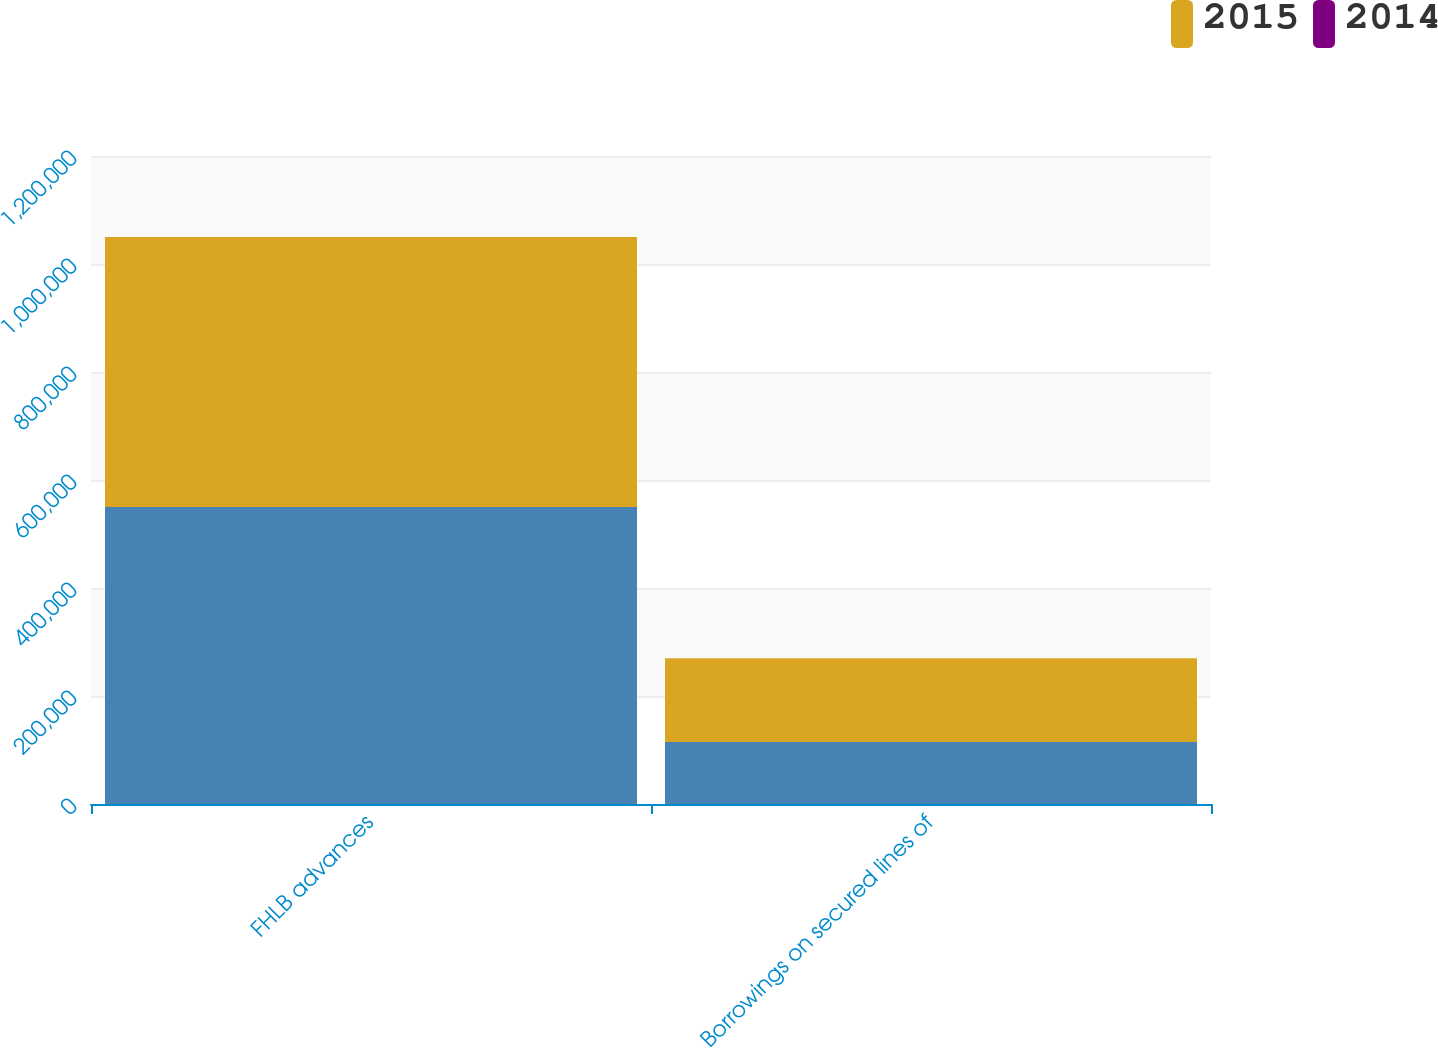Convert chart. <chart><loc_0><loc_0><loc_500><loc_500><stacked_bar_chart><ecel><fcel>FHLB advances<fcel>Borrowings on secured lines of<nl><fcel>nan<fcel>550000<fcel>115000<nl><fcel>2015<fcel>500000<fcel>154700<nl><fcel>2014<fcel>2<fcel>5<nl></chart> 